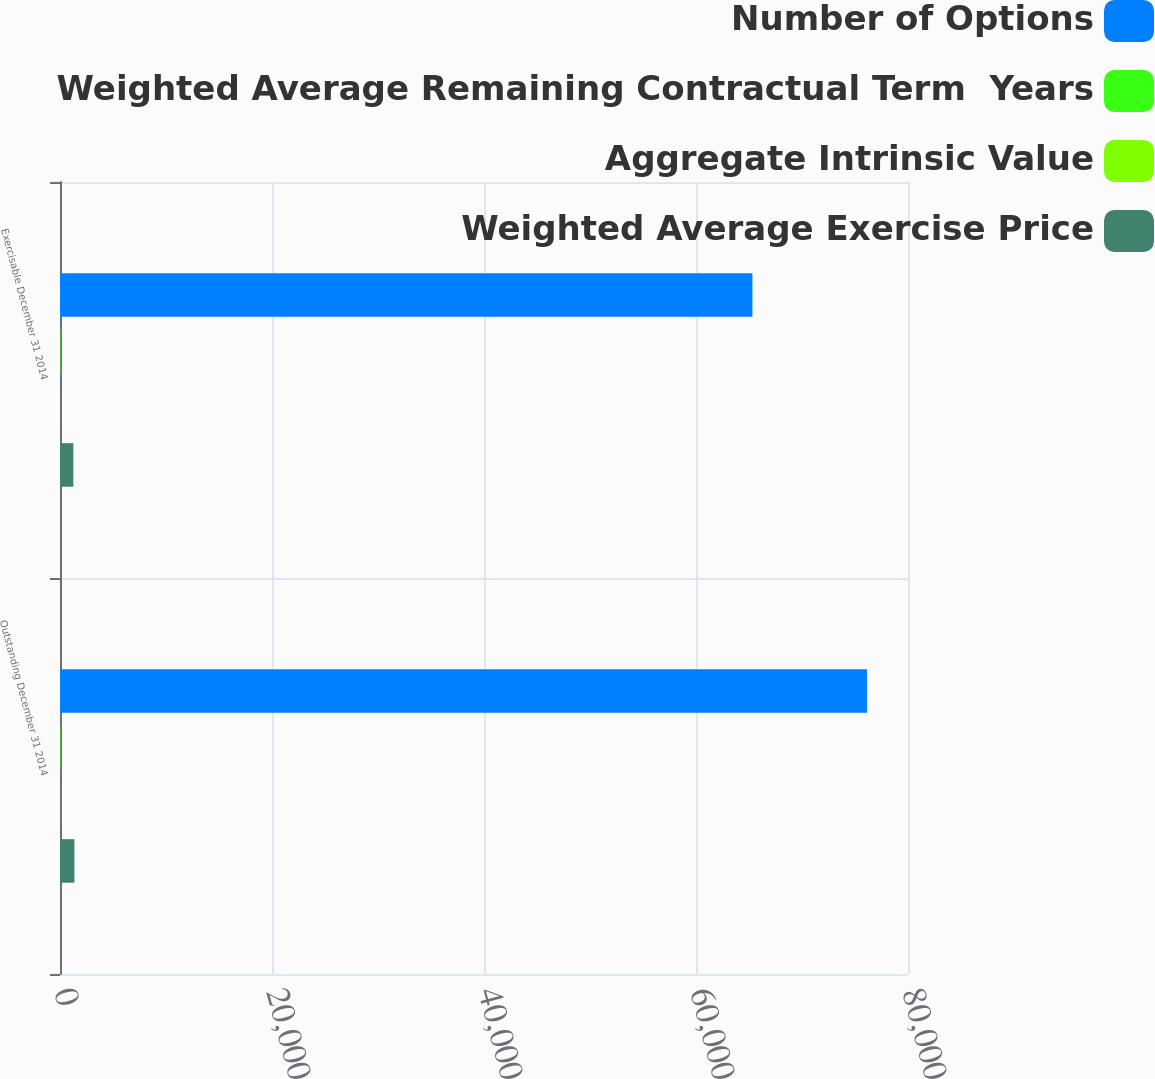Convert chart. <chart><loc_0><loc_0><loc_500><loc_500><stacked_bar_chart><ecel><fcel>Outstanding December 31 2014<fcel>Exercisable December 31 2014<nl><fcel>Number of Options<fcel>76135<fcel>65324<nl><fcel>Weighted Average Remaining Contractual Term  Years<fcel>39.05<fcel>37.56<nl><fcel>Aggregate Intrinsic Value<fcel>3.85<fcel>3.21<nl><fcel>Weighted Average Exercise Price<fcel>1358<fcel>1257<nl></chart> 